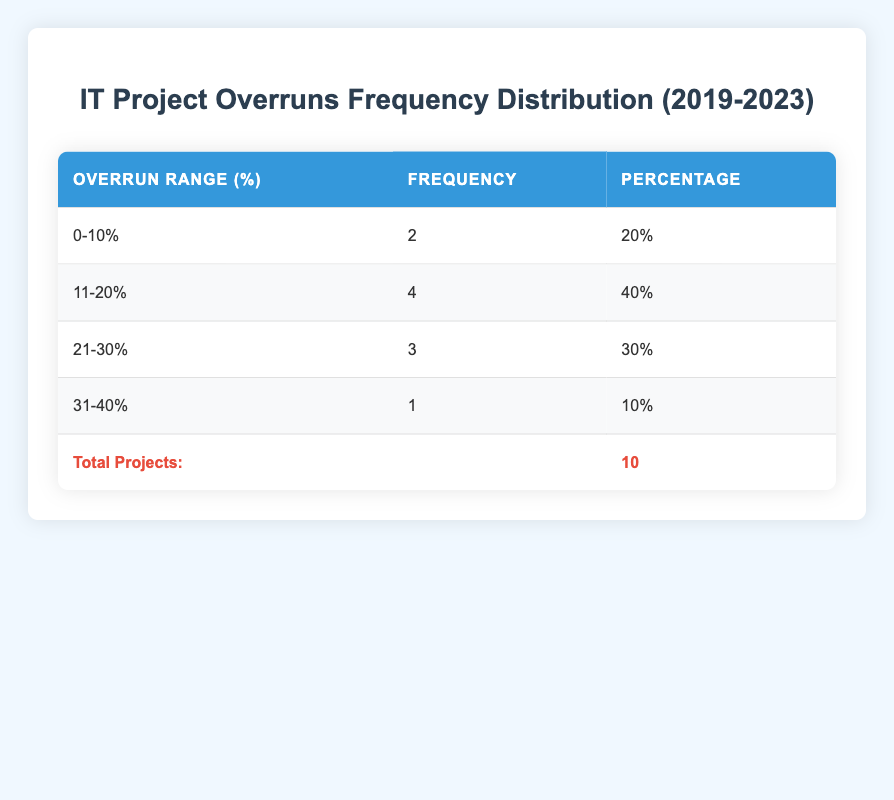What is the frequency of budget overruns in the range of 0-10%? The table shows that the frequency of budget overruns in the range of 0-10% is located in the corresponding row, which lists a frequency of 2.
Answer: 2 What percentage of total projects have budget overruns between 11% and 20%? The frequency for projects in the 11-20% range is 4. To find the percentage, divide this frequency by the total number of projects (10) and multiply by 100, resulting in (4/10)*100 = 40%.
Answer: 40% Is there any project that exceeded the budget by more than 30%? The table indicates a frequency of 1 for the range of 31-40%, which confirms that at least one project exceeded the budget by more than 30%.
Answer: Yes What is the total frequency of budget overruns greater than 20%? To find the total frequency of budget overruns greater than 20%, we need to add the frequencies of the ranges 21-30% and 31-40%, which are 3 and 1 respectively. Adding these (3 + 1) gives us a total of 4.
Answer: 4 What is the average budget overrun percentage across all projects? We can find the average by summing the total overruns: (15 + 10 + 20 + 25 + 30 + 12 + 18 + 22 + 8 + 35) =  175. Then we divide by the number of projects (10) to get the average: 175/10 = 17.5.
Answer: 17.5 